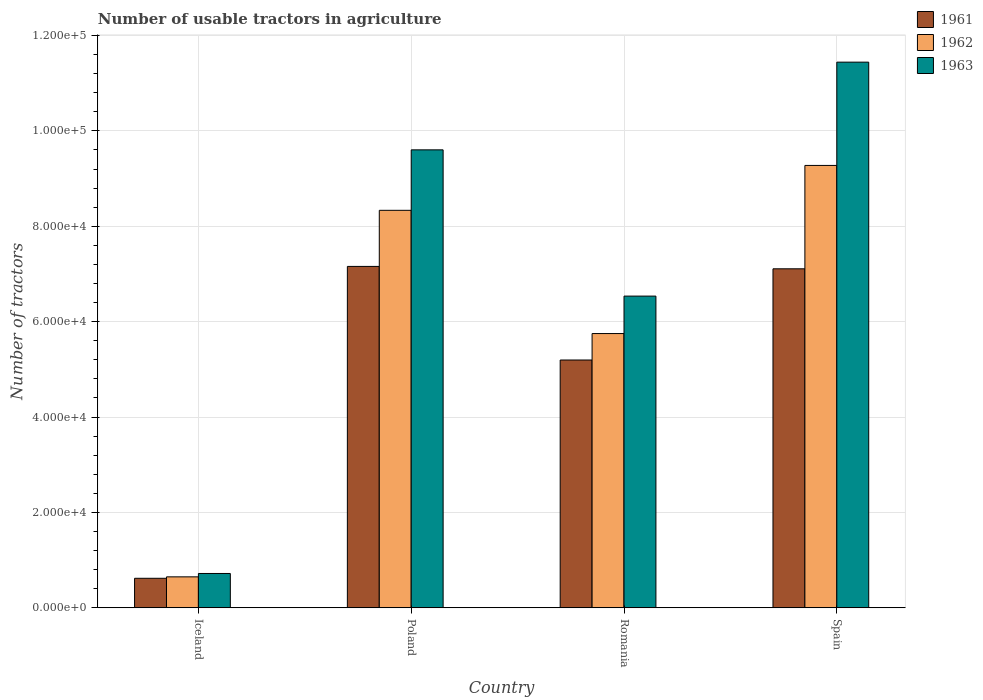How many different coloured bars are there?
Your answer should be very brief. 3. How many bars are there on the 2nd tick from the left?
Make the answer very short. 3. What is the number of usable tractors in agriculture in 1961 in Spain?
Your response must be concise. 7.11e+04. Across all countries, what is the maximum number of usable tractors in agriculture in 1962?
Make the answer very short. 9.28e+04. Across all countries, what is the minimum number of usable tractors in agriculture in 1963?
Ensure brevity in your answer.  7187. In which country was the number of usable tractors in agriculture in 1963 maximum?
Your response must be concise. Spain. What is the total number of usable tractors in agriculture in 1962 in the graph?
Your answer should be very brief. 2.40e+05. What is the difference between the number of usable tractors in agriculture in 1963 in Romania and that in Spain?
Provide a short and direct response. -4.91e+04. What is the difference between the number of usable tractors in agriculture in 1963 in Poland and the number of usable tractors in agriculture in 1962 in Romania?
Keep it short and to the point. 3.85e+04. What is the average number of usable tractors in agriculture in 1962 per country?
Give a very brief answer. 6.00e+04. What is the difference between the number of usable tractors in agriculture of/in 1961 and number of usable tractors in agriculture of/in 1962 in Iceland?
Provide a succinct answer. -302. What is the ratio of the number of usable tractors in agriculture in 1961 in Poland to that in Romania?
Provide a short and direct response. 1.38. Is the number of usable tractors in agriculture in 1963 in Poland less than that in Romania?
Ensure brevity in your answer.  No. Is the difference between the number of usable tractors in agriculture in 1961 in Iceland and Romania greater than the difference between the number of usable tractors in agriculture in 1962 in Iceland and Romania?
Ensure brevity in your answer.  Yes. What is the difference between the highest and the second highest number of usable tractors in agriculture in 1962?
Your answer should be very brief. 3.53e+04. What is the difference between the highest and the lowest number of usable tractors in agriculture in 1963?
Ensure brevity in your answer.  1.07e+05. In how many countries, is the number of usable tractors in agriculture in 1962 greater than the average number of usable tractors in agriculture in 1962 taken over all countries?
Your response must be concise. 2. Is it the case that in every country, the sum of the number of usable tractors in agriculture in 1962 and number of usable tractors in agriculture in 1961 is greater than the number of usable tractors in agriculture in 1963?
Provide a short and direct response. Yes. Are all the bars in the graph horizontal?
Give a very brief answer. No. Are the values on the major ticks of Y-axis written in scientific E-notation?
Offer a very short reply. Yes. Does the graph contain any zero values?
Keep it short and to the point. No. How are the legend labels stacked?
Ensure brevity in your answer.  Vertical. What is the title of the graph?
Provide a short and direct response. Number of usable tractors in agriculture. What is the label or title of the Y-axis?
Your answer should be compact. Number of tractors. What is the Number of tractors of 1961 in Iceland?
Make the answer very short. 6177. What is the Number of tractors of 1962 in Iceland?
Give a very brief answer. 6479. What is the Number of tractors in 1963 in Iceland?
Your answer should be compact. 7187. What is the Number of tractors of 1961 in Poland?
Your response must be concise. 7.16e+04. What is the Number of tractors in 1962 in Poland?
Keep it short and to the point. 8.33e+04. What is the Number of tractors of 1963 in Poland?
Offer a terse response. 9.60e+04. What is the Number of tractors in 1961 in Romania?
Provide a short and direct response. 5.20e+04. What is the Number of tractors of 1962 in Romania?
Your response must be concise. 5.75e+04. What is the Number of tractors of 1963 in Romania?
Provide a short and direct response. 6.54e+04. What is the Number of tractors of 1961 in Spain?
Your answer should be compact. 7.11e+04. What is the Number of tractors in 1962 in Spain?
Your answer should be compact. 9.28e+04. What is the Number of tractors of 1963 in Spain?
Your answer should be very brief. 1.14e+05. Across all countries, what is the maximum Number of tractors in 1961?
Keep it short and to the point. 7.16e+04. Across all countries, what is the maximum Number of tractors in 1962?
Your answer should be compact. 9.28e+04. Across all countries, what is the maximum Number of tractors of 1963?
Provide a succinct answer. 1.14e+05. Across all countries, what is the minimum Number of tractors in 1961?
Provide a succinct answer. 6177. Across all countries, what is the minimum Number of tractors of 1962?
Your answer should be very brief. 6479. Across all countries, what is the minimum Number of tractors of 1963?
Make the answer very short. 7187. What is the total Number of tractors in 1961 in the graph?
Your response must be concise. 2.01e+05. What is the total Number of tractors in 1962 in the graph?
Provide a short and direct response. 2.40e+05. What is the total Number of tractors in 1963 in the graph?
Give a very brief answer. 2.83e+05. What is the difference between the Number of tractors in 1961 in Iceland and that in Poland?
Provide a succinct answer. -6.54e+04. What is the difference between the Number of tractors in 1962 in Iceland and that in Poland?
Offer a very short reply. -7.69e+04. What is the difference between the Number of tractors in 1963 in Iceland and that in Poland?
Provide a short and direct response. -8.88e+04. What is the difference between the Number of tractors of 1961 in Iceland and that in Romania?
Provide a succinct answer. -4.58e+04. What is the difference between the Number of tractors of 1962 in Iceland and that in Romania?
Your response must be concise. -5.10e+04. What is the difference between the Number of tractors of 1963 in Iceland and that in Romania?
Your answer should be compact. -5.82e+04. What is the difference between the Number of tractors in 1961 in Iceland and that in Spain?
Ensure brevity in your answer.  -6.49e+04. What is the difference between the Number of tractors in 1962 in Iceland and that in Spain?
Provide a succinct answer. -8.63e+04. What is the difference between the Number of tractors in 1963 in Iceland and that in Spain?
Give a very brief answer. -1.07e+05. What is the difference between the Number of tractors in 1961 in Poland and that in Romania?
Your answer should be very brief. 1.96e+04. What is the difference between the Number of tractors in 1962 in Poland and that in Romania?
Give a very brief answer. 2.58e+04. What is the difference between the Number of tractors in 1963 in Poland and that in Romania?
Keep it short and to the point. 3.07e+04. What is the difference between the Number of tractors in 1962 in Poland and that in Spain?
Ensure brevity in your answer.  -9414. What is the difference between the Number of tractors of 1963 in Poland and that in Spain?
Offer a very short reply. -1.84e+04. What is the difference between the Number of tractors in 1961 in Romania and that in Spain?
Give a very brief answer. -1.91e+04. What is the difference between the Number of tractors in 1962 in Romania and that in Spain?
Provide a short and direct response. -3.53e+04. What is the difference between the Number of tractors in 1963 in Romania and that in Spain?
Offer a terse response. -4.91e+04. What is the difference between the Number of tractors in 1961 in Iceland and the Number of tractors in 1962 in Poland?
Provide a short and direct response. -7.72e+04. What is the difference between the Number of tractors in 1961 in Iceland and the Number of tractors in 1963 in Poland?
Your response must be concise. -8.98e+04. What is the difference between the Number of tractors in 1962 in Iceland and the Number of tractors in 1963 in Poland?
Offer a very short reply. -8.95e+04. What is the difference between the Number of tractors of 1961 in Iceland and the Number of tractors of 1962 in Romania?
Keep it short and to the point. -5.13e+04. What is the difference between the Number of tractors in 1961 in Iceland and the Number of tractors in 1963 in Romania?
Your response must be concise. -5.92e+04. What is the difference between the Number of tractors of 1962 in Iceland and the Number of tractors of 1963 in Romania?
Ensure brevity in your answer.  -5.89e+04. What is the difference between the Number of tractors in 1961 in Iceland and the Number of tractors in 1962 in Spain?
Your answer should be very brief. -8.66e+04. What is the difference between the Number of tractors of 1961 in Iceland and the Number of tractors of 1963 in Spain?
Your answer should be compact. -1.08e+05. What is the difference between the Number of tractors of 1962 in Iceland and the Number of tractors of 1963 in Spain?
Make the answer very short. -1.08e+05. What is the difference between the Number of tractors in 1961 in Poland and the Number of tractors in 1962 in Romania?
Give a very brief answer. 1.41e+04. What is the difference between the Number of tractors of 1961 in Poland and the Number of tractors of 1963 in Romania?
Provide a short and direct response. 6226. What is the difference between the Number of tractors of 1962 in Poland and the Number of tractors of 1963 in Romania?
Offer a very short reply. 1.80e+04. What is the difference between the Number of tractors of 1961 in Poland and the Number of tractors of 1962 in Spain?
Your answer should be very brief. -2.12e+04. What is the difference between the Number of tractors in 1961 in Poland and the Number of tractors in 1963 in Spain?
Offer a terse response. -4.28e+04. What is the difference between the Number of tractors of 1962 in Poland and the Number of tractors of 1963 in Spain?
Ensure brevity in your answer.  -3.11e+04. What is the difference between the Number of tractors in 1961 in Romania and the Number of tractors in 1962 in Spain?
Your answer should be very brief. -4.08e+04. What is the difference between the Number of tractors in 1961 in Romania and the Number of tractors in 1963 in Spain?
Keep it short and to the point. -6.25e+04. What is the difference between the Number of tractors of 1962 in Romania and the Number of tractors of 1963 in Spain?
Make the answer very short. -5.69e+04. What is the average Number of tractors of 1961 per country?
Provide a succinct answer. 5.02e+04. What is the average Number of tractors in 1962 per country?
Give a very brief answer. 6.00e+04. What is the average Number of tractors in 1963 per country?
Offer a very short reply. 7.07e+04. What is the difference between the Number of tractors of 1961 and Number of tractors of 1962 in Iceland?
Make the answer very short. -302. What is the difference between the Number of tractors in 1961 and Number of tractors in 1963 in Iceland?
Ensure brevity in your answer.  -1010. What is the difference between the Number of tractors in 1962 and Number of tractors in 1963 in Iceland?
Make the answer very short. -708. What is the difference between the Number of tractors of 1961 and Number of tractors of 1962 in Poland?
Provide a succinct answer. -1.18e+04. What is the difference between the Number of tractors of 1961 and Number of tractors of 1963 in Poland?
Offer a very short reply. -2.44e+04. What is the difference between the Number of tractors in 1962 and Number of tractors in 1963 in Poland?
Ensure brevity in your answer.  -1.27e+04. What is the difference between the Number of tractors of 1961 and Number of tractors of 1962 in Romania?
Provide a short and direct response. -5548. What is the difference between the Number of tractors of 1961 and Number of tractors of 1963 in Romania?
Your response must be concise. -1.34e+04. What is the difference between the Number of tractors in 1962 and Number of tractors in 1963 in Romania?
Provide a short and direct response. -7851. What is the difference between the Number of tractors of 1961 and Number of tractors of 1962 in Spain?
Give a very brief answer. -2.17e+04. What is the difference between the Number of tractors in 1961 and Number of tractors in 1963 in Spain?
Your answer should be very brief. -4.33e+04. What is the difference between the Number of tractors in 1962 and Number of tractors in 1963 in Spain?
Provide a succinct answer. -2.17e+04. What is the ratio of the Number of tractors in 1961 in Iceland to that in Poland?
Offer a very short reply. 0.09. What is the ratio of the Number of tractors of 1962 in Iceland to that in Poland?
Offer a terse response. 0.08. What is the ratio of the Number of tractors in 1963 in Iceland to that in Poland?
Ensure brevity in your answer.  0.07. What is the ratio of the Number of tractors in 1961 in Iceland to that in Romania?
Your answer should be very brief. 0.12. What is the ratio of the Number of tractors in 1962 in Iceland to that in Romania?
Your answer should be compact. 0.11. What is the ratio of the Number of tractors of 1963 in Iceland to that in Romania?
Your answer should be very brief. 0.11. What is the ratio of the Number of tractors in 1961 in Iceland to that in Spain?
Ensure brevity in your answer.  0.09. What is the ratio of the Number of tractors in 1962 in Iceland to that in Spain?
Offer a very short reply. 0.07. What is the ratio of the Number of tractors in 1963 in Iceland to that in Spain?
Your response must be concise. 0.06. What is the ratio of the Number of tractors of 1961 in Poland to that in Romania?
Your answer should be very brief. 1.38. What is the ratio of the Number of tractors of 1962 in Poland to that in Romania?
Give a very brief answer. 1.45. What is the ratio of the Number of tractors of 1963 in Poland to that in Romania?
Your answer should be very brief. 1.47. What is the ratio of the Number of tractors in 1961 in Poland to that in Spain?
Your response must be concise. 1.01. What is the ratio of the Number of tractors of 1962 in Poland to that in Spain?
Give a very brief answer. 0.9. What is the ratio of the Number of tractors of 1963 in Poland to that in Spain?
Offer a very short reply. 0.84. What is the ratio of the Number of tractors in 1961 in Romania to that in Spain?
Keep it short and to the point. 0.73. What is the ratio of the Number of tractors in 1962 in Romania to that in Spain?
Your answer should be very brief. 0.62. What is the ratio of the Number of tractors of 1963 in Romania to that in Spain?
Your response must be concise. 0.57. What is the difference between the highest and the second highest Number of tractors in 1961?
Make the answer very short. 500. What is the difference between the highest and the second highest Number of tractors in 1962?
Provide a succinct answer. 9414. What is the difference between the highest and the second highest Number of tractors of 1963?
Keep it short and to the point. 1.84e+04. What is the difference between the highest and the lowest Number of tractors of 1961?
Provide a succinct answer. 6.54e+04. What is the difference between the highest and the lowest Number of tractors of 1962?
Ensure brevity in your answer.  8.63e+04. What is the difference between the highest and the lowest Number of tractors of 1963?
Ensure brevity in your answer.  1.07e+05. 